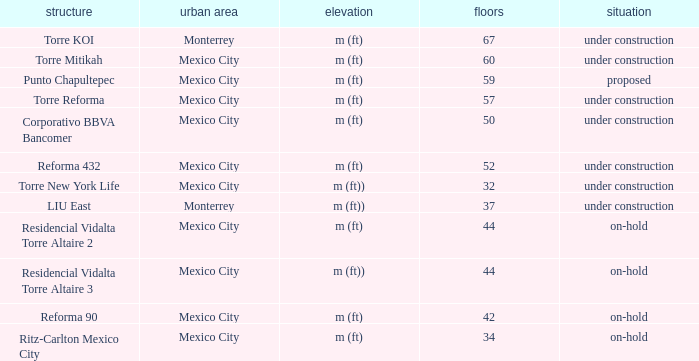What is the status of the torre reforma building that is over 44 stories in mexico city? Under construction. 